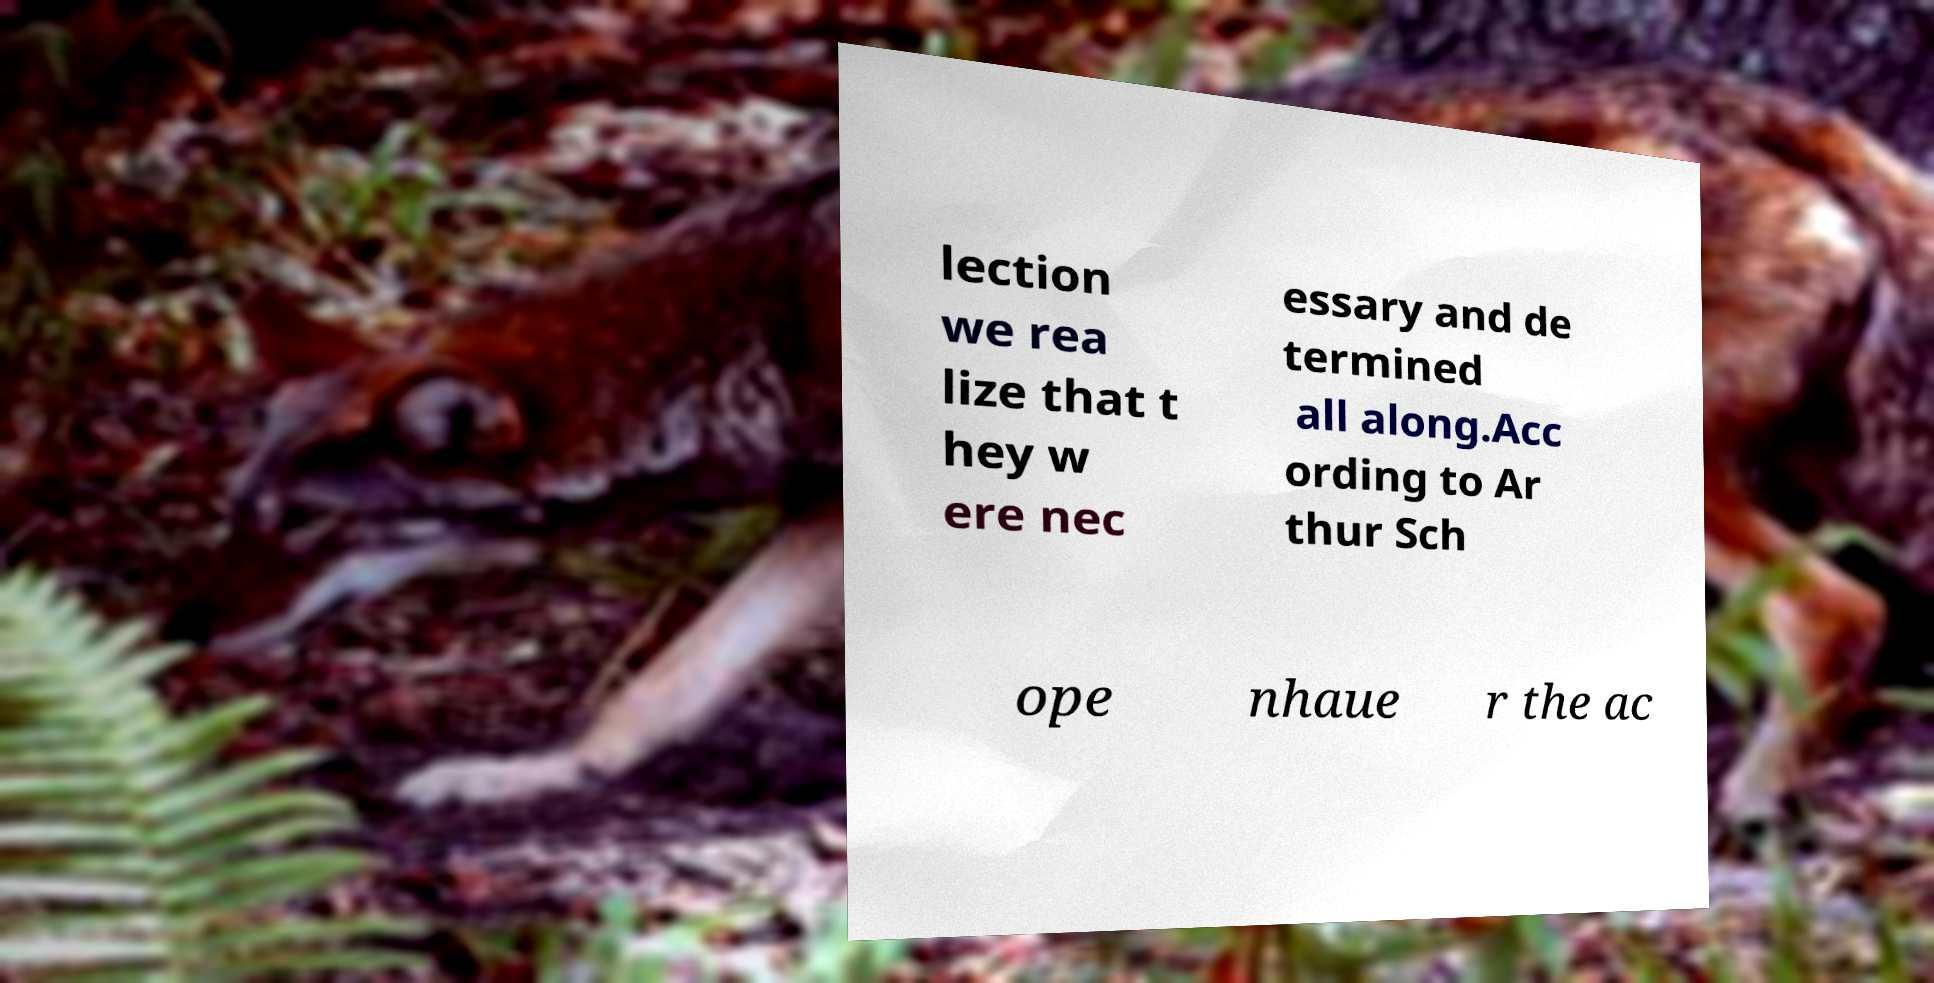Please read and relay the text visible in this image. What does it say? lection we rea lize that t hey w ere nec essary and de termined all along.Acc ording to Ar thur Sch ope nhaue r the ac 